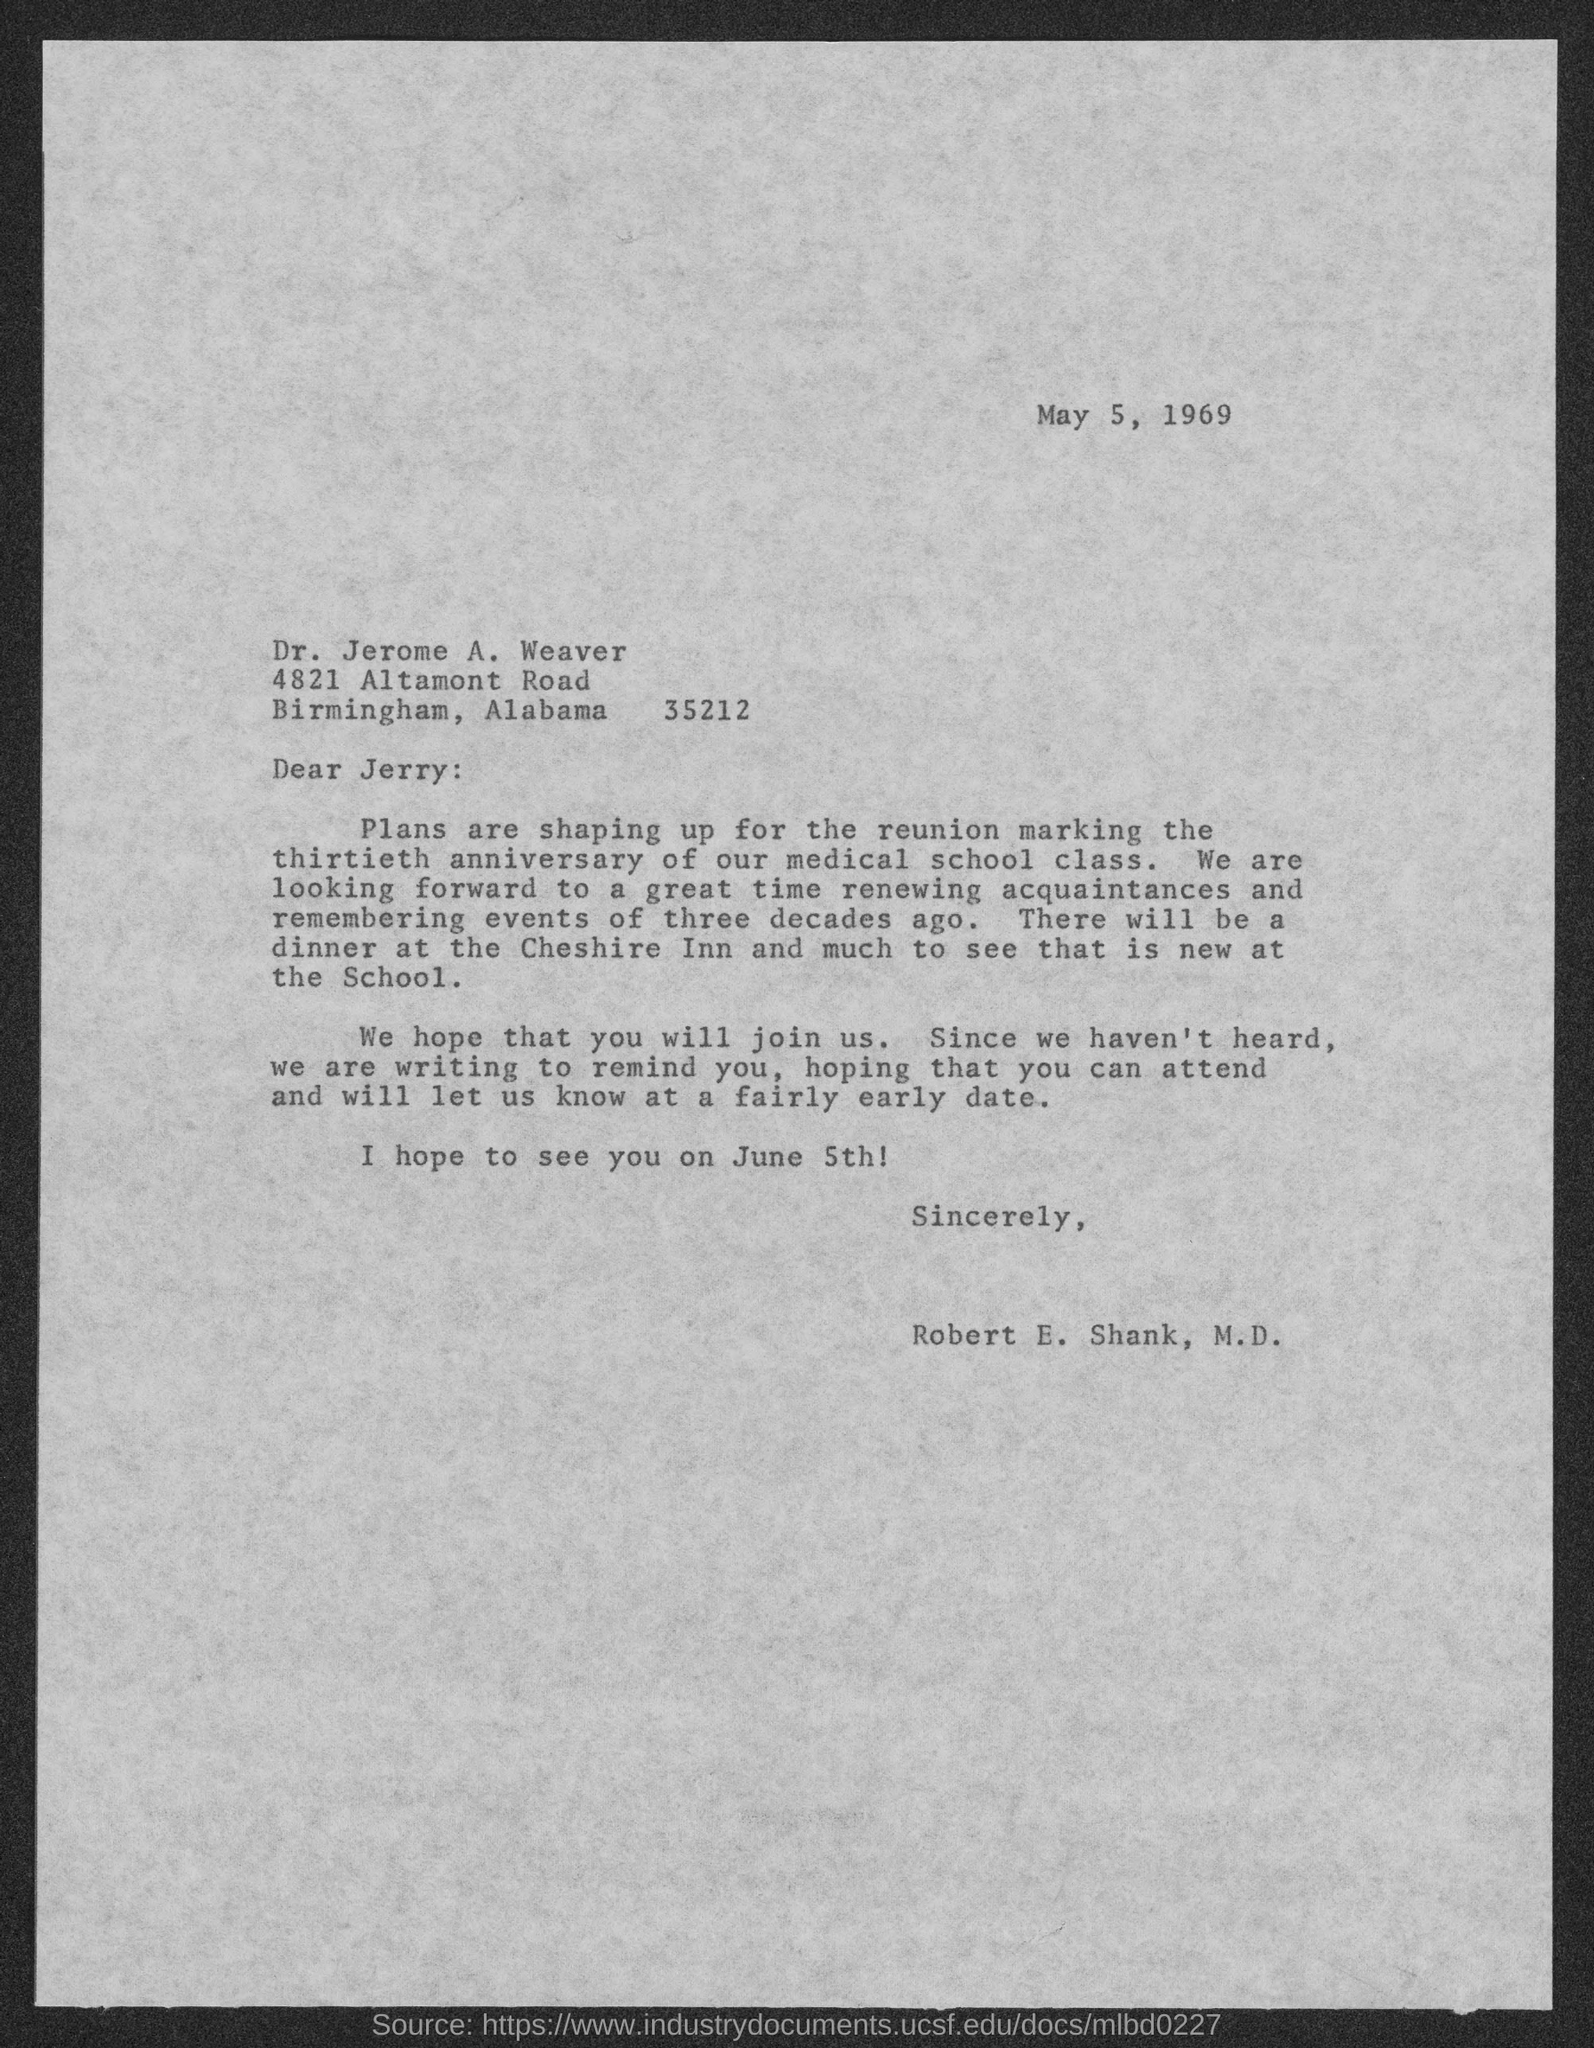When is the document dated?
Your response must be concise. May 5, 1969. To whom is the letter addressed?
Ensure brevity in your answer.  Jerry. What is the occassion for reunion?
Your answer should be compact. Marking the thirtieth anniversary of our medical school class. When is the reunion?
Offer a very short reply. June 5th. Who is the sender?
Your answer should be very brief. Robert E. Shank. 